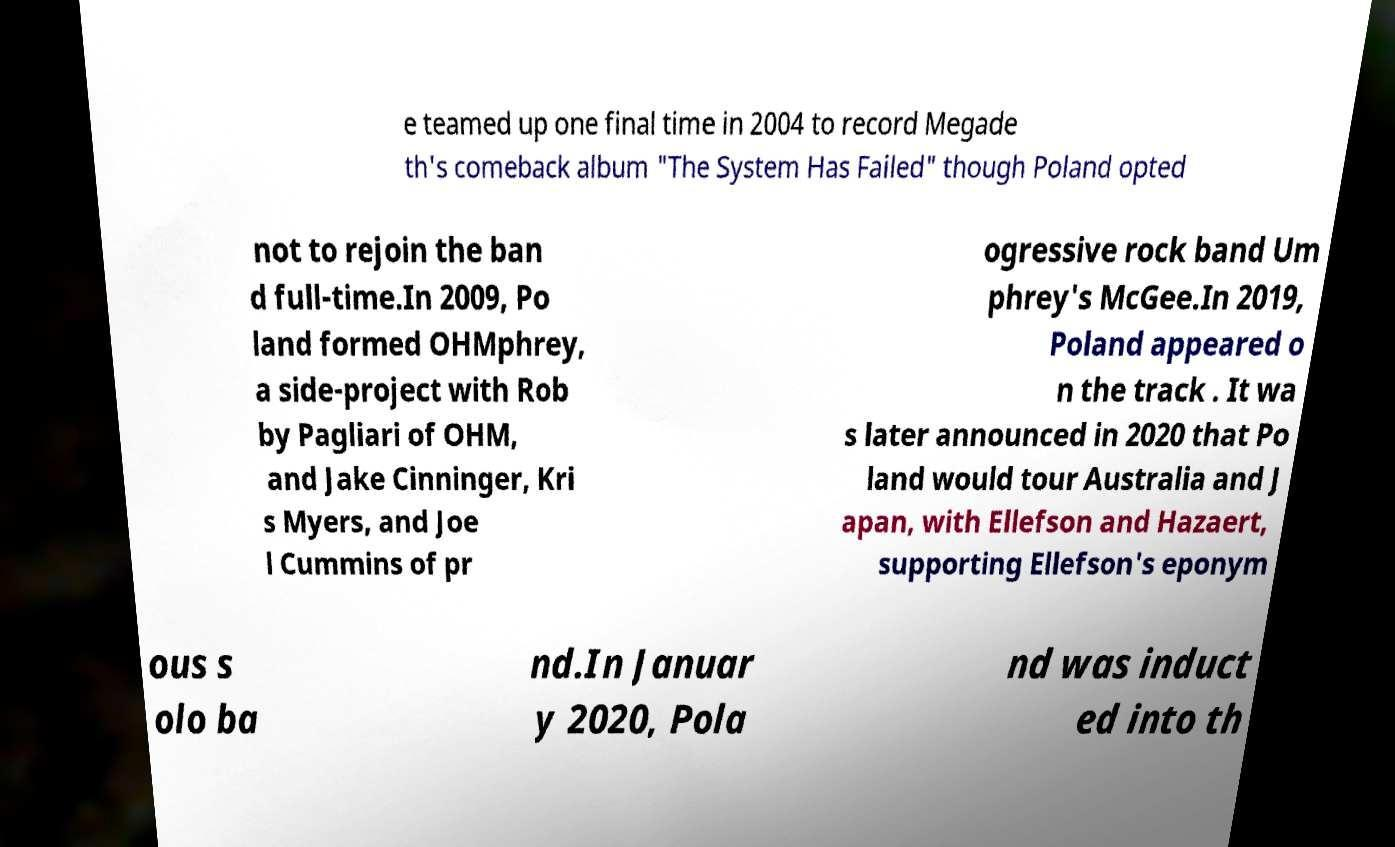Can you accurately transcribe the text from the provided image for me? e teamed up one final time in 2004 to record Megade th's comeback album "The System Has Failed" though Poland opted not to rejoin the ban d full-time.In 2009, Po land formed OHMphrey, a side-project with Rob by Pagliari of OHM, and Jake Cinninger, Kri s Myers, and Joe l Cummins of pr ogressive rock band Um phrey's McGee.In 2019, Poland appeared o n the track . It wa s later announced in 2020 that Po land would tour Australia and J apan, with Ellefson and Hazaert, supporting Ellefson's eponym ous s olo ba nd.In Januar y 2020, Pola nd was induct ed into th 